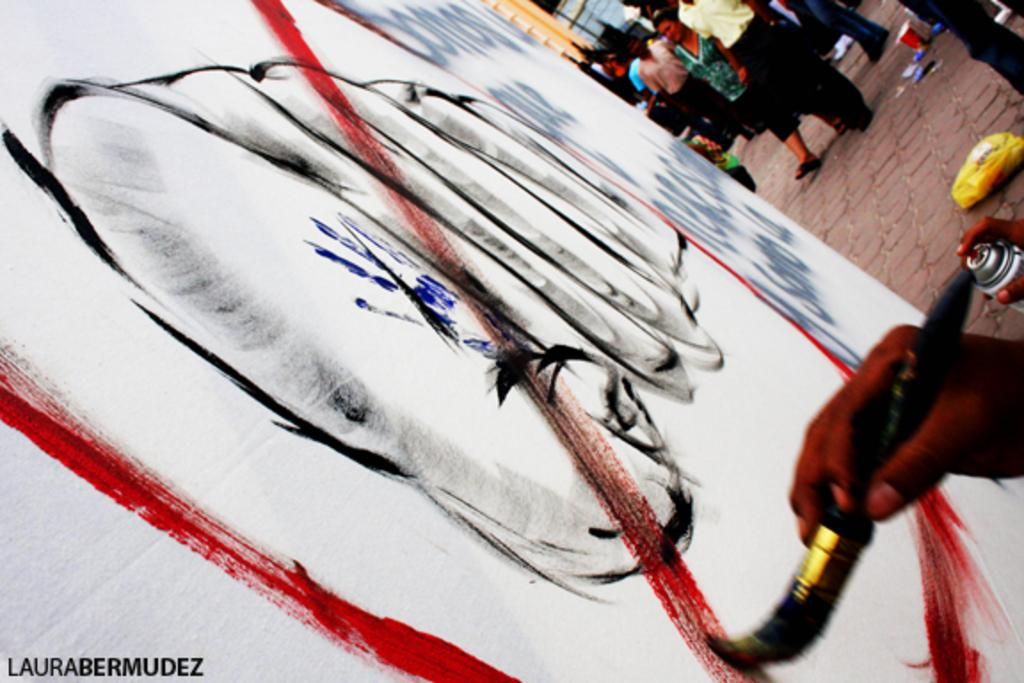What is the person in the image holding? The person is holding a paintbrush in the image. What is the person doing with the paintbrush? The person is painting. Are there any other people visible in the image? Yes, there are other persons standing in the background of the image. Reasoning: Let's think step by identifying the main subject in the image, which is the person holding a paintbrush. Then, we describe the action the person is performing, which is painting. Finally, we mention the presence of other people in the background. Each question is designed to elicit a specific detail about the image that is known from the provided facts. Absurd Question/Answer: What type of pizzas are being served to the people in the image? There are no pizzas present in the image; it features a person holding a paintbrush and painting. Which arm is the person using to hold the paintbrush in the image? The provided facts do not specify which arm the person is using to hold the paintbrush, so it cannot be determined from the image. 